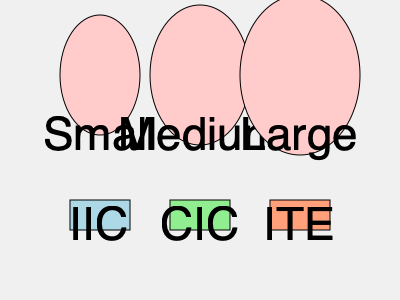As a mother who has experienced the joy of her child regaining hearing, which hearing aid style would you likely recommend for a child with small ear canals to ensure comfort and discretion? 1. Understand the ear sizes presented:
   - Small
   - Medium
   - Large

2. Identify the hearing aid styles shown:
   - IIC (Invisible-In-Canal)
   - CIC (Completely-In-Canal)
   - ITE (In-The-Ear)

3. Consider the characteristics of each hearing aid style:
   - IIC: Smallest and most discreet, fits deep in the ear canal
   - CIC: Very small, fits completely in the ear canal
   - ITE: Larger, fills the outer portion of the ear

4. Match the hearing aid style to the ear size:
   - For small ear canals, the smallest hearing aid would be most suitable

5. Consider the child's needs:
   - Comfort is crucial for consistent use
   - Discretion may help with self-confidence

6. Conclude that the IIC (Invisible-In-Canal) would be the best recommendation:
   - It's the smallest option, ideal for small ear canals
   - Provides the most discretion, which can be important for a child
   - Ensures comfort due to its custom fit deep in the ear canal
Answer: IIC (Invisible-In-Canal) 